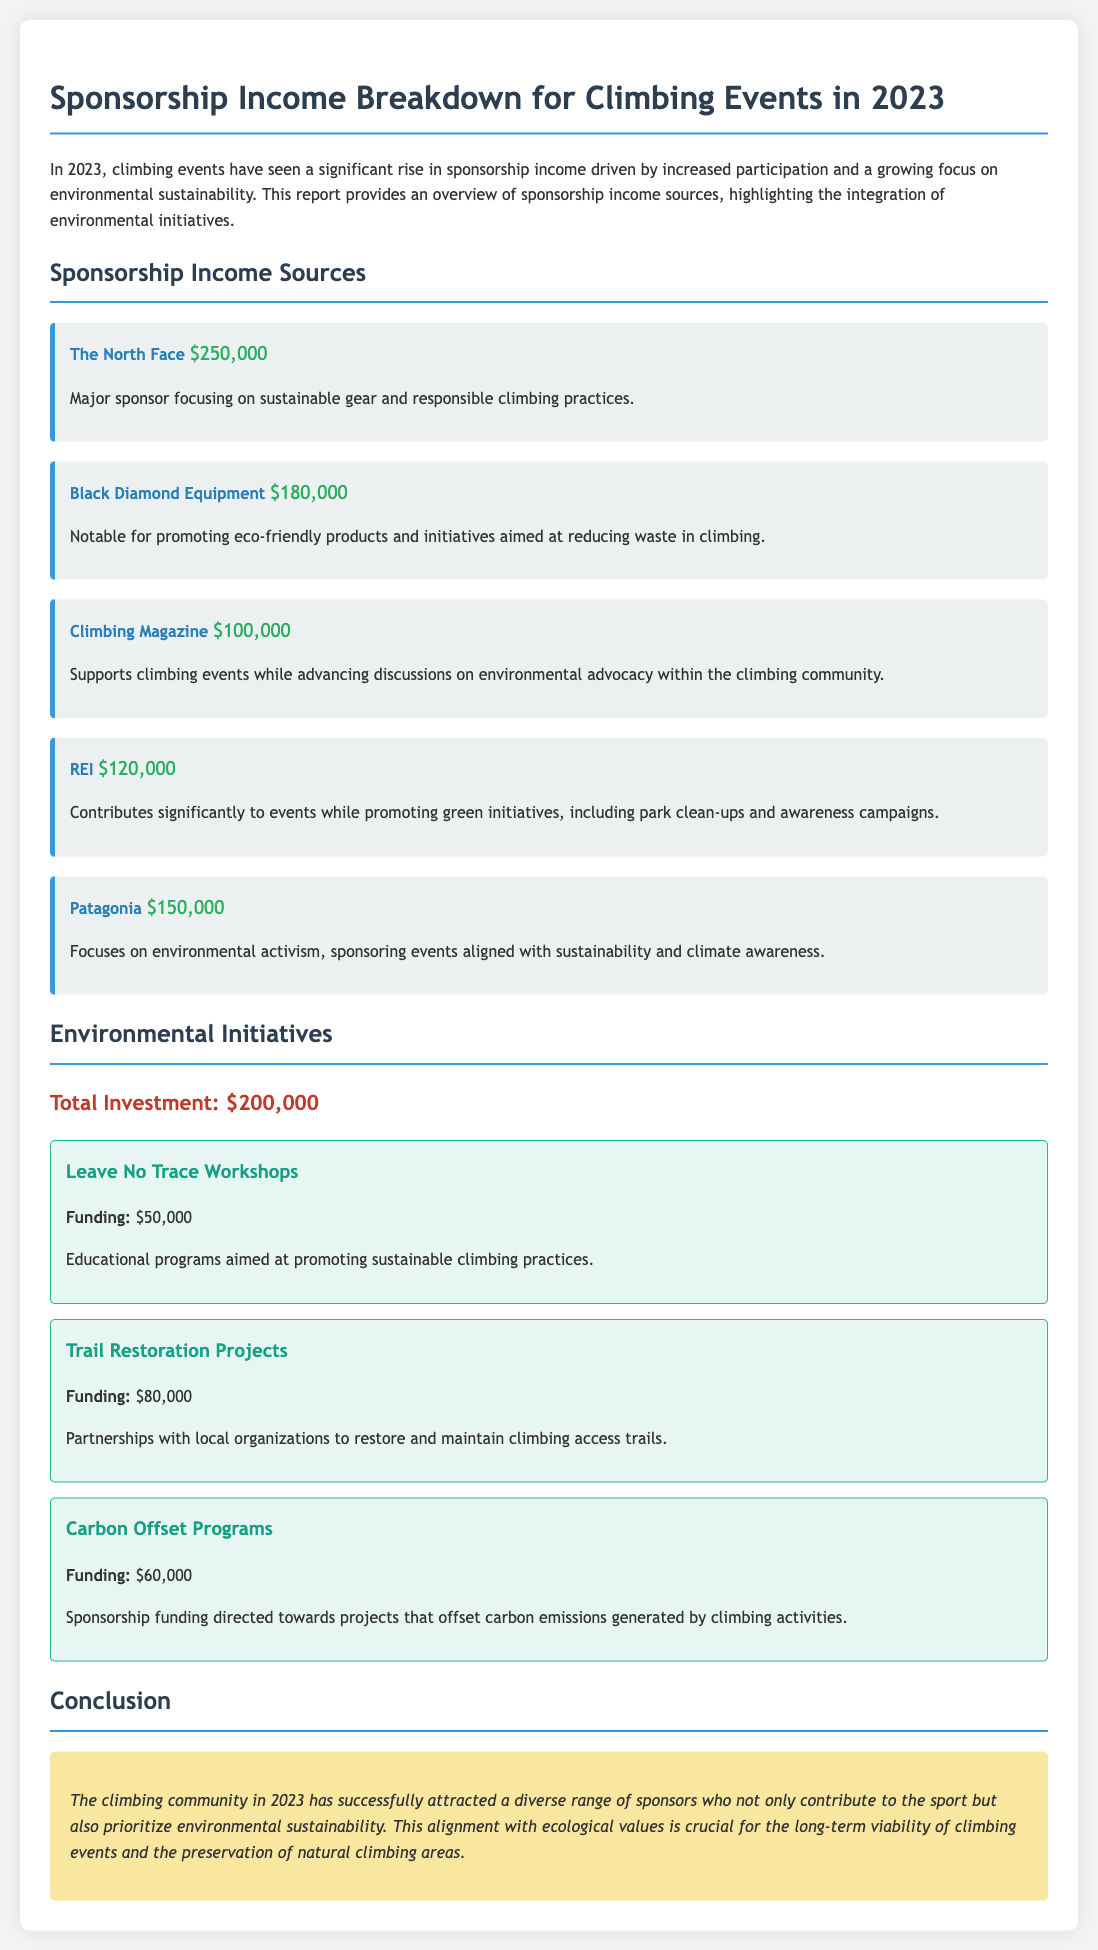What is the total sponsorship income from The North Face? The total sponsorship income from The North Face listed in the document is $250,000.
Answer: $250,000 How much funding is allocated for Trail Restoration Projects? The funding allocated for Trail Restoration Projects as mentioned in the document is $80,000.
Answer: $80,000 Which company is not specifically noted for environmental initiatives? Climbing Magazine is primarily focused on advancing discussions on environmental advocacy rather than directly promoting eco-friendly products.
Answer: Climbing Magazine What is the total investment in environmental initiatives? The total investment in environmental initiatives is a cumulative amount detailed in the document, which sums to $200,000.
Answer: $200,000 Which sponsor is known for its environmental activism? Patagonia is the sponsor identified in the document that focuses on environmental activism.
Answer: Patagonia What percentage of the total sponsorship income is contributed by REI? REI's income of $120,000 out of the total sponsorship income (which will have to be calculated) represents a certain percentage that involves reasoning through the total, which is $1,000,000.
Answer: 12% How many sponsors are listed in the sponsorship income sources? The document includes five sponsors listed for climbing events in 2023.
Answer: Five What is the primary focus of Black Diamond Equipment's sponsorship? Black Diamond Equipment focuses on promoting eco-friendly products and initiatives aimed at reducing waste in climbing.
Answer: Eco-friendly products What initiative received the highest funding? The initiative with the highest funding is the Trail Restoration Projects, with $80,000 allocated.
Answer: Trail Restoration Projects 